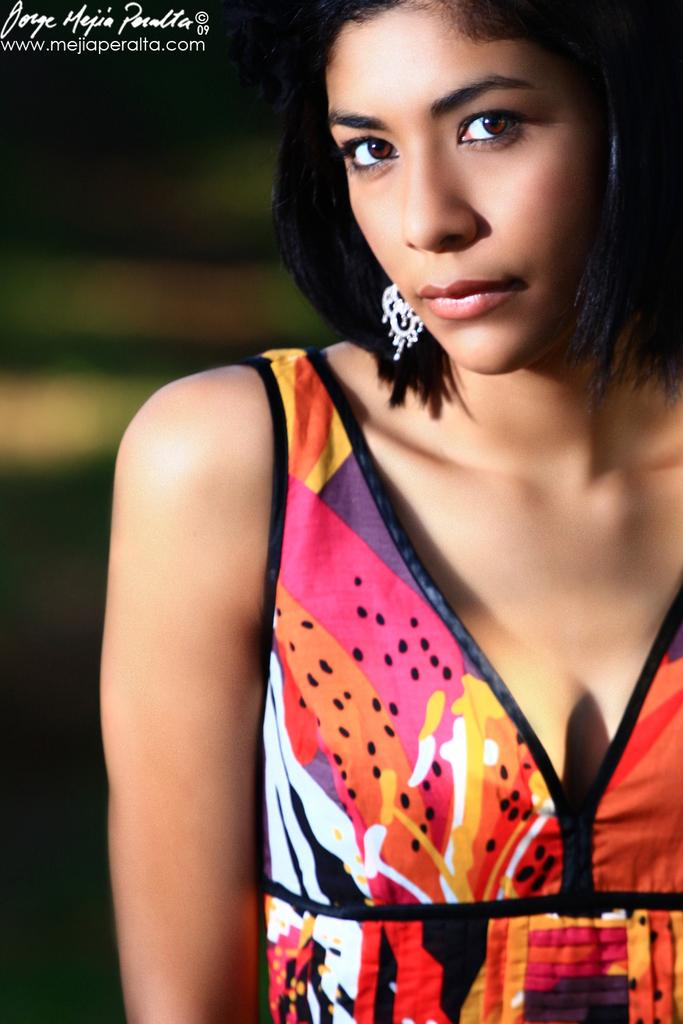What can be seen in the top left corner of the image? There is a watermark on the top left of the image. Who is present in the image? There is a woman in the image. What is the woman doing in the image? The woman is watching something. Can you describe the background of the image? The background of the image is blurred. What is the profit margin of the dad in the image? There is no dad present in the image, and therefore no information about a profit margin can be provided. 